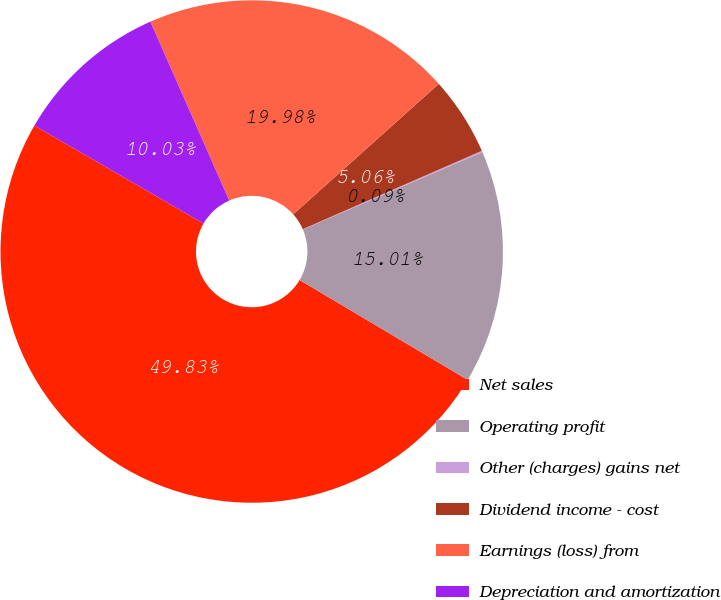<chart> <loc_0><loc_0><loc_500><loc_500><pie_chart><fcel>Net sales<fcel>Operating profit<fcel>Other (charges) gains net<fcel>Dividend income - cost<fcel>Earnings (loss) from<fcel>Depreciation and amortization<nl><fcel>49.83%<fcel>15.01%<fcel>0.09%<fcel>5.06%<fcel>19.98%<fcel>10.03%<nl></chart> 